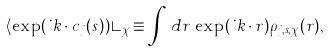<formula> <loc_0><loc_0><loc_500><loc_500>\langle \exp ( i { k \cdot c } _ { j } ( s ) ) \rangle _ { \chi } \equiv \int \, d { r } \, \exp ( i { k \cdot r } ) \rho _ { j , s , \chi } ( { r } ) ,</formula> 